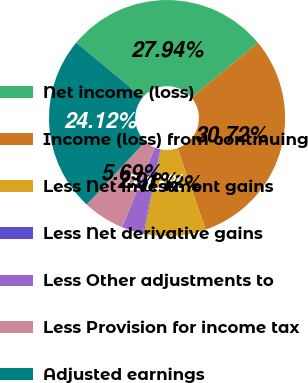Convert chart to OTSL. <chart><loc_0><loc_0><loc_500><loc_500><pie_chart><fcel>Net income (loss)<fcel>Income (loss) from continuing<fcel>Less Net investment gains<fcel>Less Net derivative gains<fcel>Less Other adjustments to<fcel>Less Provision for income tax<fcel>Adjusted earnings<nl><fcel>27.94%<fcel>30.72%<fcel>8.48%<fcel>0.13%<fcel>2.91%<fcel>5.69%<fcel>24.12%<nl></chart> 